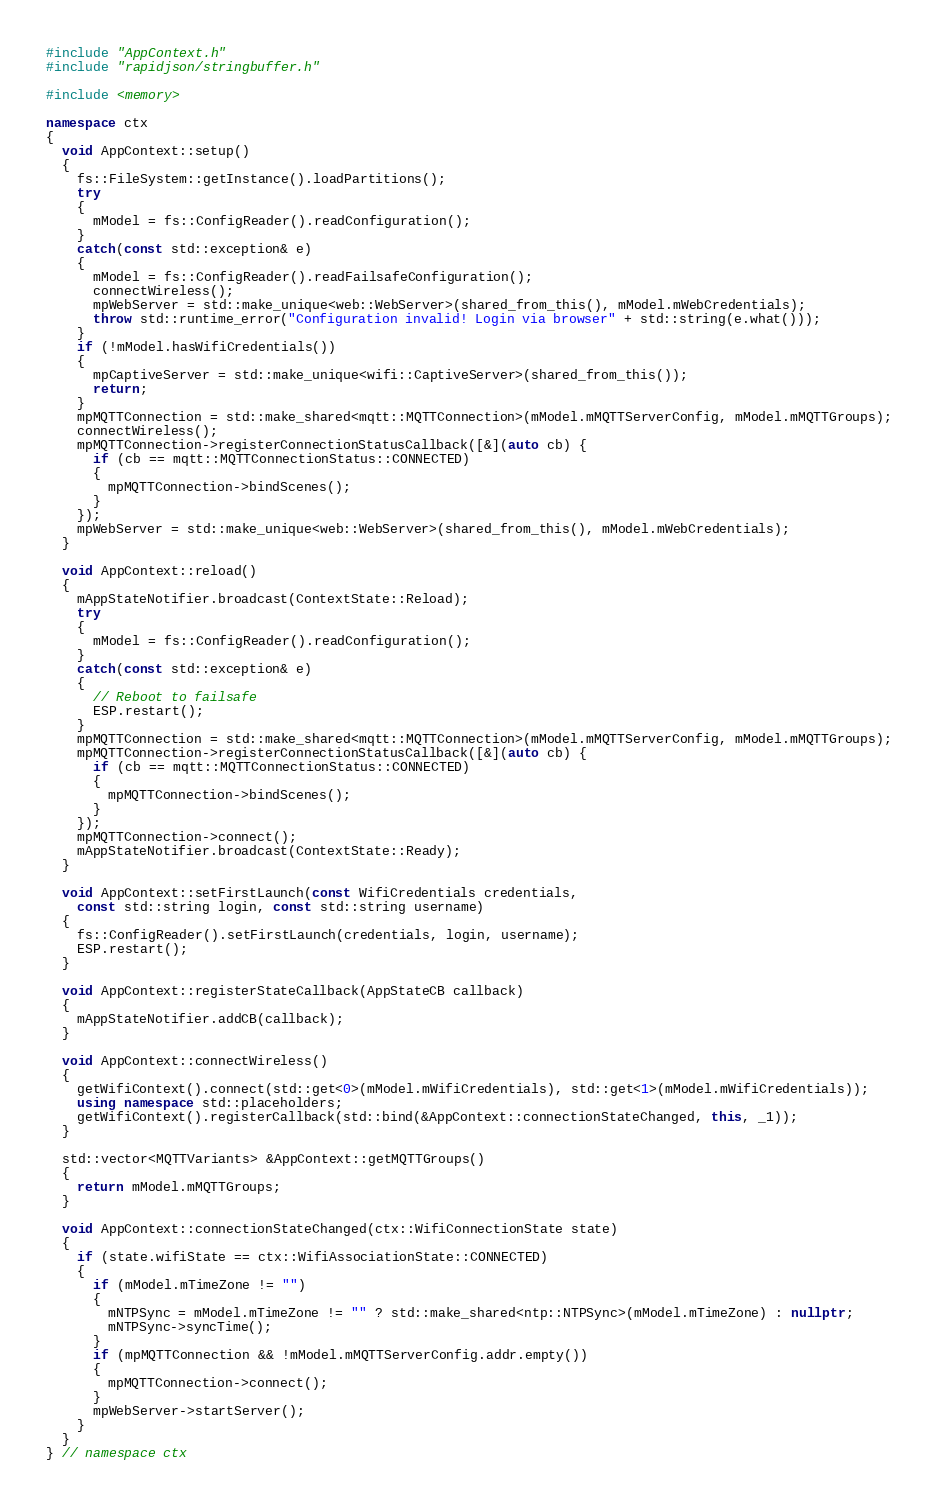<code> <loc_0><loc_0><loc_500><loc_500><_C++_>#include "AppContext.h"
#include "rapidjson/stringbuffer.h"

#include <memory>

namespace ctx
{
  void AppContext::setup()
  {
    fs::FileSystem::getInstance().loadPartitions();
    try
    {
      mModel = fs::ConfigReader().readConfiguration();
    }
    catch(const std::exception& e)
    {
      mModel = fs::ConfigReader().readFailsafeConfiguration();
      connectWireless();
      mpWebServer = std::make_unique<web::WebServer>(shared_from_this(), mModel.mWebCredentials);
      throw std::runtime_error("Configuration invalid! Login via browser" + std::string(e.what()));
    }
    if (!mModel.hasWifiCredentials())
    {
      mpCaptiveServer = std::make_unique<wifi::CaptiveServer>(shared_from_this());
      return;
    }
    mpMQTTConnection = std::make_shared<mqtt::MQTTConnection>(mModel.mMQTTServerConfig, mModel.mMQTTGroups);
    connectWireless();
    mpMQTTConnection->registerConnectionStatusCallback([&](auto cb) {
      if (cb == mqtt::MQTTConnectionStatus::CONNECTED)
      {
        mpMQTTConnection->bindScenes();
      }
    });
    mpWebServer = std::make_unique<web::WebServer>(shared_from_this(), mModel.mWebCredentials);
  }

  void AppContext::reload()
  {
    mAppStateNotifier.broadcast(ContextState::Reload);
    try
    {
      mModel = fs::ConfigReader().readConfiguration();
    }
    catch(const std::exception& e)
    {
      // Reboot to failsafe
      ESP.restart();
    }
    mpMQTTConnection = std::make_shared<mqtt::MQTTConnection>(mModel.mMQTTServerConfig, mModel.mMQTTGroups);
    mpMQTTConnection->registerConnectionStatusCallback([&](auto cb) {
      if (cb == mqtt::MQTTConnectionStatus::CONNECTED)
      {
        mpMQTTConnection->bindScenes();
      }
    });
    mpMQTTConnection->connect();
    mAppStateNotifier.broadcast(ContextState::Ready);
  }

  void AppContext::setFirstLaunch(const WifiCredentials credentials,
    const std::string login, const std::string username)
  {
    fs::ConfigReader().setFirstLaunch(credentials, login, username);
    ESP.restart();
  }

  void AppContext::registerStateCallback(AppStateCB callback)
  {
    mAppStateNotifier.addCB(callback);
  }

  void AppContext::connectWireless()
  {
    getWifiContext().connect(std::get<0>(mModel.mWifiCredentials), std::get<1>(mModel.mWifiCredentials));
    using namespace std::placeholders;
    getWifiContext().registerCallback(std::bind(&AppContext::connectionStateChanged, this, _1));
  }

  std::vector<MQTTVariants> &AppContext::getMQTTGroups()
  {
    return mModel.mMQTTGroups;
  }

  void AppContext::connectionStateChanged(ctx::WifiConnectionState state)
  {
    if (state.wifiState == ctx::WifiAssociationState::CONNECTED)
    {
      if (mModel.mTimeZone != "")
      {
        mNTPSync = mModel.mTimeZone != "" ? std::make_shared<ntp::NTPSync>(mModel.mTimeZone) : nullptr;
        mNTPSync->syncTime();
      }
      if (mpMQTTConnection && !mModel.mMQTTServerConfig.addr.empty())
      {
        mpMQTTConnection->connect();
      }
      mpWebServer->startServer();
    }
  }
} // namespace ctx
</code> 